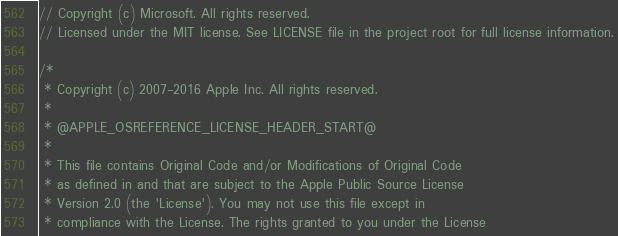<code> <loc_0><loc_0><loc_500><loc_500><_C_>// Copyright (c) Microsoft. All rights reserved.
// Licensed under the MIT license. See LICENSE file in the project root for full license information.

/*
 * Copyright (c) 2007-2016 Apple Inc. All rights reserved.
 *
 * @APPLE_OSREFERENCE_LICENSE_HEADER_START@
 * 
 * This file contains Original Code and/or Modifications of Original Code
 * as defined in and that are subject to the Apple Public Source License
 * Version 2.0 (the 'License'). You may not use this file except in
 * compliance with the License. The rights granted to you under the License</code> 